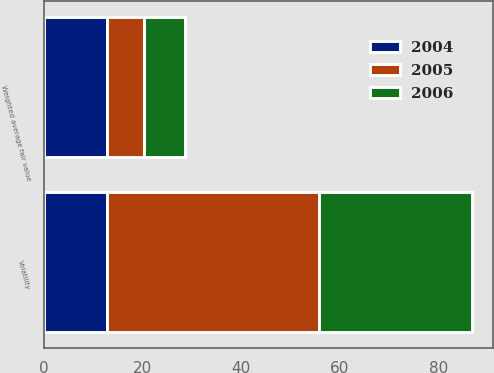Convert chart. <chart><loc_0><loc_0><loc_500><loc_500><stacked_bar_chart><ecel><fcel>Weighted average fair value<fcel>Volatility<nl><fcel>2004<fcel>12.75<fcel>12.75<nl><fcel>2006<fcel>8.49<fcel>31<nl><fcel>2005<fcel>7.44<fcel>43<nl></chart> 